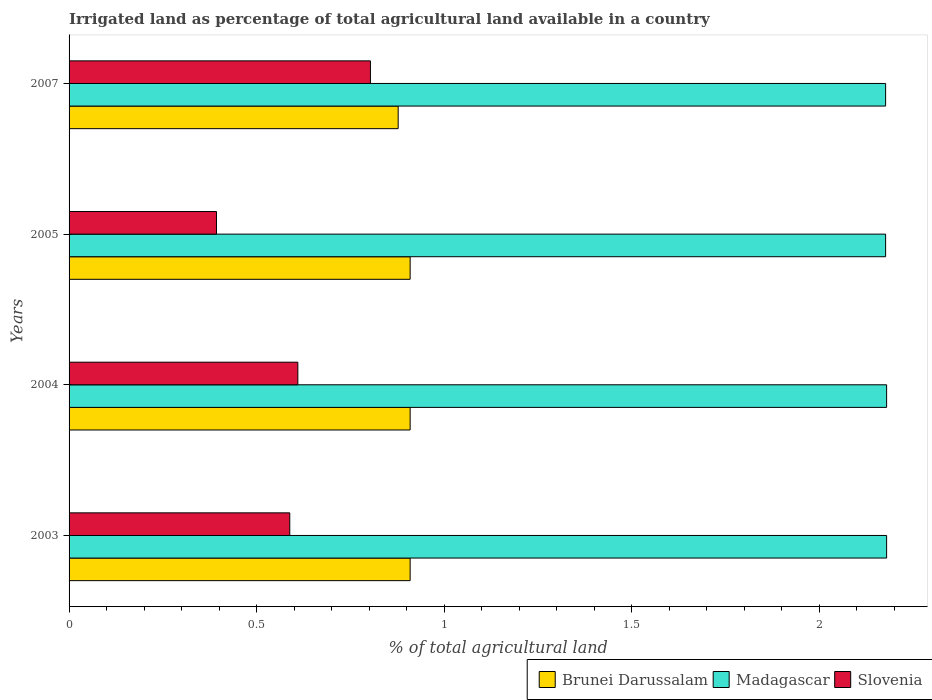How many different coloured bars are there?
Your answer should be very brief. 3. How many groups of bars are there?
Make the answer very short. 4. Are the number of bars per tick equal to the number of legend labels?
Your answer should be compact. Yes. What is the percentage of irrigated land in Slovenia in 2007?
Ensure brevity in your answer.  0.8. Across all years, what is the maximum percentage of irrigated land in Slovenia?
Provide a short and direct response. 0.8. Across all years, what is the minimum percentage of irrigated land in Madagascar?
Ensure brevity in your answer.  2.18. What is the total percentage of irrigated land in Slovenia in the graph?
Offer a very short reply. 2.39. What is the difference between the percentage of irrigated land in Slovenia in 2005 and that in 2007?
Keep it short and to the point. -0.41. What is the difference between the percentage of irrigated land in Brunei Darussalam in 2004 and the percentage of irrigated land in Slovenia in 2005?
Offer a terse response. 0.52. What is the average percentage of irrigated land in Madagascar per year?
Give a very brief answer. 2.18. In the year 2005, what is the difference between the percentage of irrigated land in Brunei Darussalam and percentage of irrigated land in Slovenia?
Your answer should be compact. 0.52. In how many years, is the percentage of irrigated land in Brunei Darussalam greater than 1.1 %?
Your answer should be compact. 0. What is the ratio of the percentage of irrigated land in Brunei Darussalam in 2004 to that in 2007?
Provide a succinct answer. 1.04. Is the difference between the percentage of irrigated land in Brunei Darussalam in 2004 and 2005 greater than the difference between the percentage of irrigated land in Slovenia in 2004 and 2005?
Give a very brief answer. No. What is the difference between the highest and the second highest percentage of irrigated land in Slovenia?
Provide a short and direct response. 0.19. What is the difference between the highest and the lowest percentage of irrigated land in Slovenia?
Give a very brief answer. 0.41. In how many years, is the percentage of irrigated land in Madagascar greater than the average percentage of irrigated land in Madagascar taken over all years?
Keep it short and to the point. 2. Is the sum of the percentage of irrigated land in Brunei Darussalam in 2003 and 2005 greater than the maximum percentage of irrigated land in Madagascar across all years?
Keep it short and to the point. No. What does the 2nd bar from the top in 2004 represents?
Keep it short and to the point. Madagascar. What does the 1st bar from the bottom in 2007 represents?
Ensure brevity in your answer.  Brunei Darussalam. Is it the case that in every year, the sum of the percentage of irrigated land in Slovenia and percentage of irrigated land in Madagascar is greater than the percentage of irrigated land in Brunei Darussalam?
Your answer should be very brief. Yes. Are all the bars in the graph horizontal?
Your answer should be very brief. Yes. Does the graph contain any zero values?
Your response must be concise. No. Does the graph contain grids?
Make the answer very short. No. How many legend labels are there?
Make the answer very short. 3. What is the title of the graph?
Give a very brief answer. Irrigated land as percentage of total agricultural land available in a country. What is the label or title of the X-axis?
Provide a succinct answer. % of total agricultural land. What is the % of total agricultural land of Brunei Darussalam in 2003?
Your answer should be very brief. 0.91. What is the % of total agricultural land of Madagascar in 2003?
Ensure brevity in your answer.  2.18. What is the % of total agricultural land in Slovenia in 2003?
Offer a very short reply. 0.59. What is the % of total agricultural land in Brunei Darussalam in 2004?
Your response must be concise. 0.91. What is the % of total agricultural land in Madagascar in 2004?
Provide a short and direct response. 2.18. What is the % of total agricultural land of Slovenia in 2004?
Make the answer very short. 0.61. What is the % of total agricultural land in Brunei Darussalam in 2005?
Your response must be concise. 0.91. What is the % of total agricultural land in Madagascar in 2005?
Your answer should be compact. 2.18. What is the % of total agricultural land of Slovenia in 2005?
Offer a very short reply. 0.39. What is the % of total agricultural land of Brunei Darussalam in 2007?
Provide a short and direct response. 0.88. What is the % of total agricultural land in Madagascar in 2007?
Ensure brevity in your answer.  2.18. What is the % of total agricultural land in Slovenia in 2007?
Ensure brevity in your answer.  0.8. Across all years, what is the maximum % of total agricultural land of Brunei Darussalam?
Your response must be concise. 0.91. Across all years, what is the maximum % of total agricultural land of Madagascar?
Keep it short and to the point. 2.18. Across all years, what is the maximum % of total agricultural land in Slovenia?
Offer a terse response. 0.8. Across all years, what is the minimum % of total agricultural land of Brunei Darussalam?
Offer a very short reply. 0.88. Across all years, what is the minimum % of total agricultural land in Madagascar?
Offer a very short reply. 2.18. Across all years, what is the minimum % of total agricultural land of Slovenia?
Your answer should be very brief. 0.39. What is the total % of total agricultural land of Brunei Darussalam in the graph?
Keep it short and to the point. 3.6. What is the total % of total agricultural land in Madagascar in the graph?
Make the answer very short. 8.71. What is the total % of total agricultural land of Slovenia in the graph?
Offer a very short reply. 2.39. What is the difference between the % of total agricultural land of Brunei Darussalam in 2003 and that in 2004?
Your response must be concise. 0. What is the difference between the % of total agricultural land in Slovenia in 2003 and that in 2004?
Offer a very short reply. -0.02. What is the difference between the % of total agricultural land in Madagascar in 2003 and that in 2005?
Offer a terse response. 0. What is the difference between the % of total agricultural land in Slovenia in 2003 and that in 2005?
Make the answer very short. 0.2. What is the difference between the % of total agricultural land of Brunei Darussalam in 2003 and that in 2007?
Keep it short and to the point. 0.03. What is the difference between the % of total agricultural land of Madagascar in 2003 and that in 2007?
Your answer should be very brief. 0. What is the difference between the % of total agricultural land of Slovenia in 2003 and that in 2007?
Your response must be concise. -0.21. What is the difference between the % of total agricultural land of Madagascar in 2004 and that in 2005?
Make the answer very short. 0. What is the difference between the % of total agricultural land in Slovenia in 2004 and that in 2005?
Provide a short and direct response. 0.22. What is the difference between the % of total agricultural land in Brunei Darussalam in 2004 and that in 2007?
Offer a very short reply. 0.03. What is the difference between the % of total agricultural land in Madagascar in 2004 and that in 2007?
Provide a succinct answer. 0. What is the difference between the % of total agricultural land in Slovenia in 2004 and that in 2007?
Provide a succinct answer. -0.19. What is the difference between the % of total agricultural land of Brunei Darussalam in 2005 and that in 2007?
Give a very brief answer. 0.03. What is the difference between the % of total agricultural land of Slovenia in 2005 and that in 2007?
Your response must be concise. -0.41. What is the difference between the % of total agricultural land of Brunei Darussalam in 2003 and the % of total agricultural land of Madagascar in 2004?
Provide a succinct answer. -1.27. What is the difference between the % of total agricultural land of Brunei Darussalam in 2003 and the % of total agricultural land of Slovenia in 2004?
Make the answer very short. 0.3. What is the difference between the % of total agricultural land of Madagascar in 2003 and the % of total agricultural land of Slovenia in 2004?
Provide a succinct answer. 1.57. What is the difference between the % of total agricultural land in Brunei Darussalam in 2003 and the % of total agricultural land in Madagascar in 2005?
Offer a terse response. -1.27. What is the difference between the % of total agricultural land of Brunei Darussalam in 2003 and the % of total agricultural land of Slovenia in 2005?
Your response must be concise. 0.52. What is the difference between the % of total agricultural land of Madagascar in 2003 and the % of total agricultural land of Slovenia in 2005?
Your answer should be very brief. 1.79. What is the difference between the % of total agricultural land in Brunei Darussalam in 2003 and the % of total agricultural land in Madagascar in 2007?
Provide a succinct answer. -1.27. What is the difference between the % of total agricultural land of Brunei Darussalam in 2003 and the % of total agricultural land of Slovenia in 2007?
Your response must be concise. 0.11. What is the difference between the % of total agricultural land of Madagascar in 2003 and the % of total agricultural land of Slovenia in 2007?
Your answer should be very brief. 1.38. What is the difference between the % of total agricultural land of Brunei Darussalam in 2004 and the % of total agricultural land of Madagascar in 2005?
Give a very brief answer. -1.27. What is the difference between the % of total agricultural land in Brunei Darussalam in 2004 and the % of total agricultural land in Slovenia in 2005?
Make the answer very short. 0.52. What is the difference between the % of total agricultural land in Madagascar in 2004 and the % of total agricultural land in Slovenia in 2005?
Give a very brief answer. 1.79. What is the difference between the % of total agricultural land of Brunei Darussalam in 2004 and the % of total agricultural land of Madagascar in 2007?
Keep it short and to the point. -1.27. What is the difference between the % of total agricultural land of Brunei Darussalam in 2004 and the % of total agricultural land of Slovenia in 2007?
Offer a terse response. 0.11. What is the difference between the % of total agricultural land in Madagascar in 2004 and the % of total agricultural land in Slovenia in 2007?
Keep it short and to the point. 1.38. What is the difference between the % of total agricultural land in Brunei Darussalam in 2005 and the % of total agricultural land in Madagascar in 2007?
Keep it short and to the point. -1.27. What is the difference between the % of total agricultural land in Brunei Darussalam in 2005 and the % of total agricultural land in Slovenia in 2007?
Your answer should be very brief. 0.11. What is the difference between the % of total agricultural land of Madagascar in 2005 and the % of total agricultural land of Slovenia in 2007?
Provide a short and direct response. 1.37. What is the average % of total agricultural land in Brunei Darussalam per year?
Your answer should be compact. 0.9. What is the average % of total agricultural land of Madagascar per year?
Offer a terse response. 2.18. What is the average % of total agricultural land in Slovenia per year?
Give a very brief answer. 0.6. In the year 2003, what is the difference between the % of total agricultural land of Brunei Darussalam and % of total agricultural land of Madagascar?
Make the answer very short. -1.27. In the year 2003, what is the difference between the % of total agricultural land in Brunei Darussalam and % of total agricultural land in Slovenia?
Make the answer very short. 0.32. In the year 2003, what is the difference between the % of total agricultural land of Madagascar and % of total agricultural land of Slovenia?
Keep it short and to the point. 1.59. In the year 2004, what is the difference between the % of total agricultural land of Brunei Darussalam and % of total agricultural land of Madagascar?
Offer a terse response. -1.27. In the year 2004, what is the difference between the % of total agricultural land of Brunei Darussalam and % of total agricultural land of Slovenia?
Make the answer very short. 0.3. In the year 2004, what is the difference between the % of total agricultural land in Madagascar and % of total agricultural land in Slovenia?
Your answer should be compact. 1.57. In the year 2005, what is the difference between the % of total agricultural land of Brunei Darussalam and % of total agricultural land of Madagascar?
Your answer should be very brief. -1.27. In the year 2005, what is the difference between the % of total agricultural land of Brunei Darussalam and % of total agricultural land of Slovenia?
Your response must be concise. 0.52. In the year 2005, what is the difference between the % of total agricultural land in Madagascar and % of total agricultural land in Slovenia?
Provide a succinct answer. 1.78. In the year 2007, what is the difference between the % of total agricultural land of Brunei Darussalam and % of total agricultural land of Madagascar?
Ensure brevity in your answer.  -1.3. In the year 2007, what is the difference between the % of total agricultural land of Brunei Darussalam and % of total agricultural land of Slovenia?
Offer a very short reply. 0.07. In the year 2007, what is the difference between the % of total agricultural land of Madagascar and % of total agricultural land of Slovenia?
Give a very brief answer. 1.37. What is the ratio of the % of total agricultural land in Slovenia in 2003 to that in 2004?
Give a very brief answer. 0.96. What is the ratio of the % of total agricultural land in Slovenia in 2003 to that in 2005?
Offer a terse response. 1.5. What is the ratio of the % of total agricultural land in Brunei Darussalam in 2003 to that in 2007?
Your answer should be very brief. 1.04. What is the ratio of the % of total agricultural land of Slovenia in 2003 to that in 2007?
Ensure brevity in your answer.  0.73. What is the ratio of the % of total agricultural land of Brunei Darussalam in 2004 to that in 2005?
Ensure brevity in your answer.  1. What is the ratio of the % of total agricultural land of Slovenia in 2004 to that in 2005?
Your answer should be compact. 1.55. What is the ratio of the % of total agricultural land in Brunei Darussalam in 2004 to that in 2007?
Keep it short and to the point. 1.04. What is the ratio of the % of total agricultural land in Slovenia in 2004 to that in 2007?
Your response must be concise. 0.76. What is the ratio of the % of total agricultural land of Brunei Darussalam in 2005 to that in 2007?
Give a very brief answer. 1.04. What is the ratio of the % of total agricultural land of Madagascar in 2005 to that in 2007?
Make the answer very short. 1. What is the ratio of the % of total agricultural land in Slovenia in 2005 to that in 2007?
Offer a very short reply. 0.49. What is the difference between the highest and the second highest % of total agricultural land of Brunei Darussalam?
Keep it short and to the point. 0. What is the difference between the highest and the second highest % of total agricultural land of Madagascar?
Give a very brief answer. 0. What is the difference between the highest and the second highest % of total agricultural land of Slovenia?
Your answer should be compact. 0.19. What is the difference between the highest and the lowest % of total agricultural land in Brunei Darussalam?
Your answer should be compact. 0.03. What is the difference between the highest and the lowest % of total agricultural land in Madagascar?
Keep it short and to the point. 0. What is the difference between the highest and the lowest % of total agricultural land in Slovenia?
Ensure brevity in your answer.  0.41. 